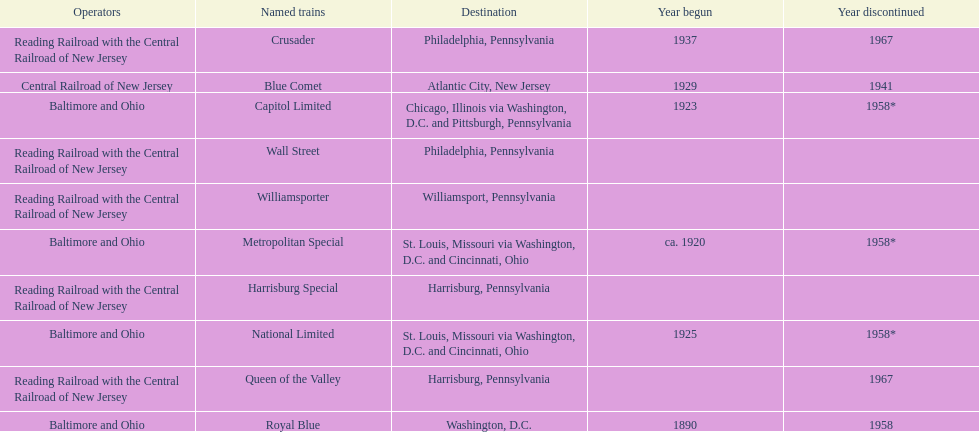What was the first train to begin service? Royal Blue. 